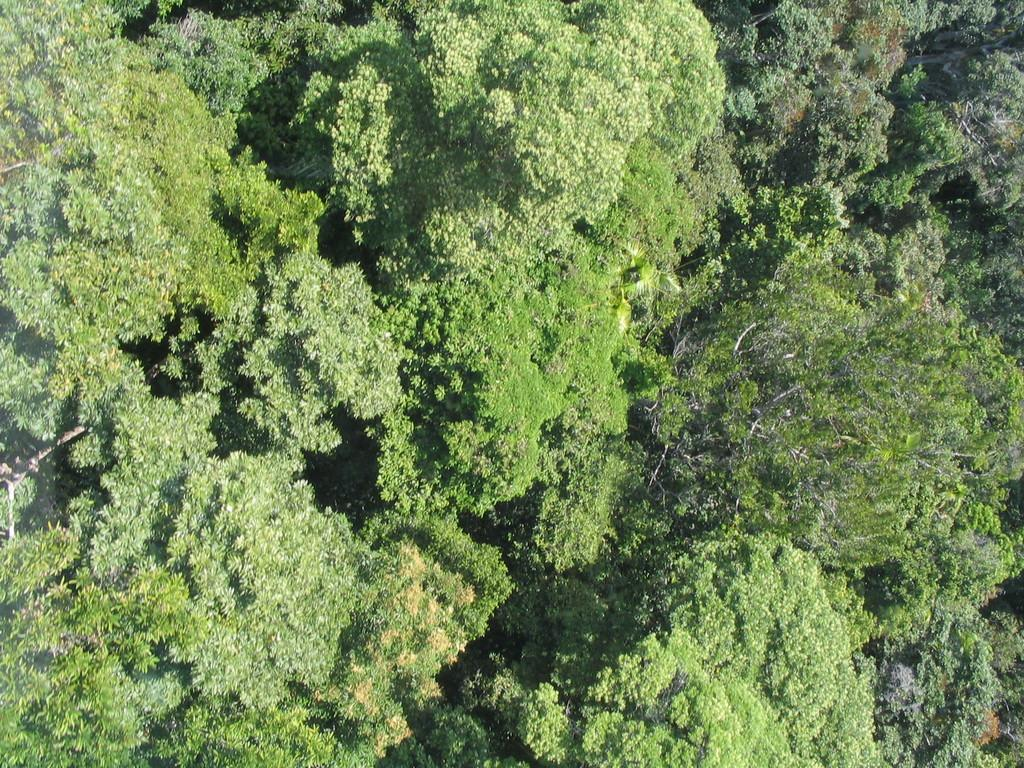What type of setting is depicted in the image? The image contains an outside view. What type of vegetation can be seen in the image? There is a group of trees in the image. What type of fear can be seen on the legs of the trees in the image? There is no fear present on the trees in the image, as trees do not have emotions or legs. What season is depicted in the image? The provided facts do not specify the season depicted in the image. 